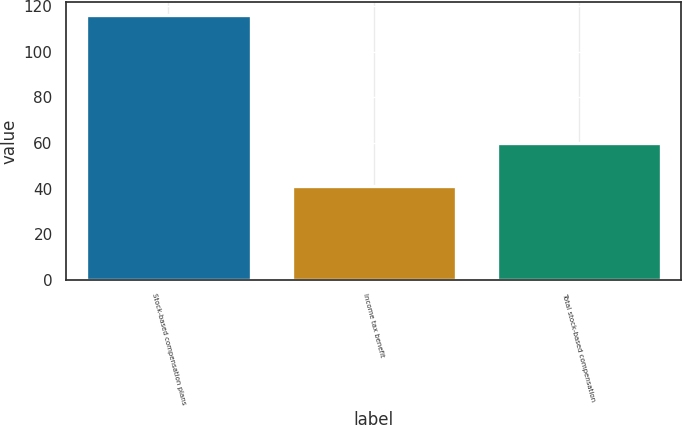Convert chart. <chart><loc_0><loc_0><loc_500><loc_500><bar_chart><fcel>Stock-based compensation plans<fcel>Income tax benefit<fcel>Total stock-based compensation<nl><fcel>116<fcel>41<fcel>60<nl></chart> 